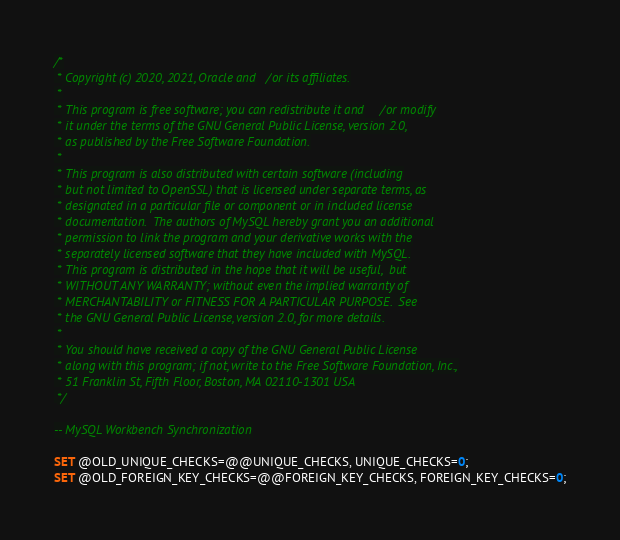<code> <loc_0><loc_0><loc_500><loc_500><_SQL_>/*
 * Copyright (c) 2020, 2021, Oracle and/or its affiliates.
 *
 * This program is free software; you can redistribute it and/or modify
 * it under the terms of the GNU General Public License, version 2.0,
 * as published by the Free Software Foundation.
 *
 * This program is also distributed with certain software (including
 * but not limited to OpenSSL) that is licensed under separate terms, as
 * designated in a particular file or component or in included license
 * documentation.  The authors of MySQL hereby grant you an additional
 * permission to link the program and your derivative works with the
 * separately licensed software that they have included with MySQL.
 * This program is distributed in the hope that it will be useful,  but
 * WITHOUT ANY WARRANTY; without even the implied warranty of
 * MERCHANTABILITY or FITNESS FOR A PARTICULAR PURPOSE.  See
 * the GNU General Public License, version 2.0, for more details.
 *
 * You should have received a copy of the GNU General Public License
 * along with this program; if not, write to the Free Software Foundation, Inc.,
 * 51 Franklin St, Fifth Floor, Boston, MA 02110-1301 USA
 */

-- MySQL Workbench Synchronization

SET @OLD_UNIQUE_CHECKS=@@UNIQUE_CHECKS, UNIQUE_CHECKS=0;
SET @OLD_FOREIGN_KEY_CHECKS=@@FOREIGN_KEY_CHECKS, FOREIGN_KEY_CHECKS=0;</code> 